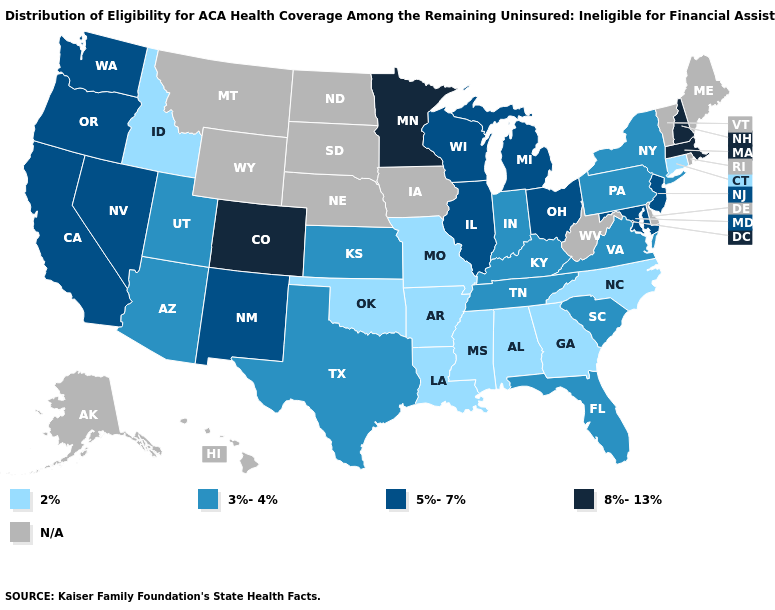What is the highest value in states that border Maine?
Be succinct. 8%-13%. What is the lowest value in states that border South Dakota?
Be succinct. 8%-13%. How many symbols are there in the legend?
Be succinct. 5. Name the states that have a value in the range 3%-4%?
Short answer required. Arizona, Florida, Indiana, Kansas, Kentucky, New York, Pennsylvania, South Carolina, Tennessee, Texas, Utah, Virginia. How many symbols are there in the legend?
Short answer required. 5. Name the states that have a value in the range 5%-7%?
Be succinct. California, Illinois, Maryland, Michigan, Nevada, New Jersey, New Mexico, Ohio, Oregon, Washington, Wisconsin. What is the value of Louisiana?
Keep it brief. 2%. What is the value of South Dakota?
Keep it brief. N/A. What is the value of Georgia?
Short answer required. 2%. Among the states that border Arizona , does Colorado have the highest value?
Give a very brief answer. Yes. What is the highest value in the South ?
Concise answer only. 5%-7%. Does the map have missing data?
Concise answer only. Yes. Does Illinois have the lowest value in the USA?
Concise answer only. No. 